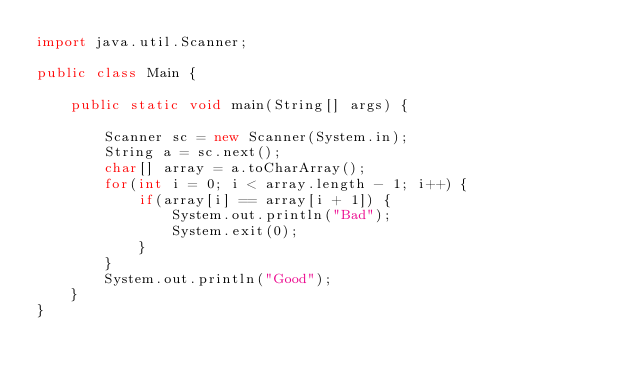<code> <loc_0><loc_0><loc_500><loc_500><_Java_>import java.util.Scanner;

public class Main {

	public static void main(String[] args) {
		
		Scanner sc = new Scanner(System.in);
		String a = sc.next();
		char[] array = a.toCharArray();
		for(int i = 0; i < array.length - 1; i++) {
			if(array[i] == array[i + 1]) {
				System.out.println("Bad");
				System.exit(0);
			}
		}
		System.out.println("Good");
	}
}</code> 